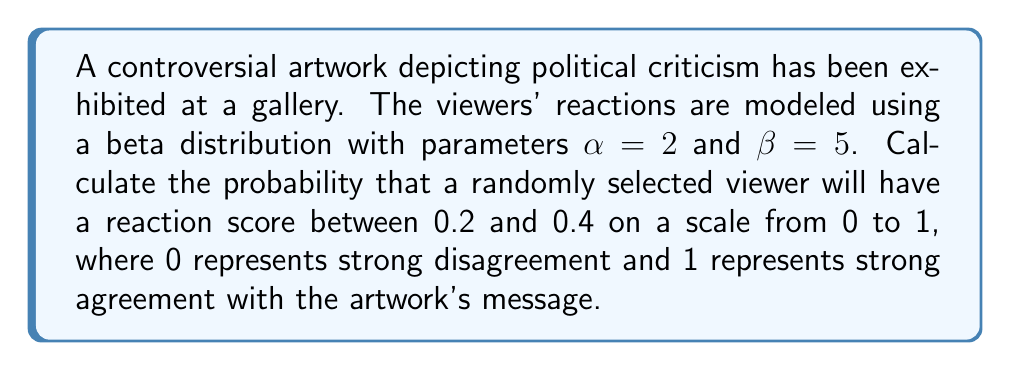Solve this math problem. To solve this problem, we need to use the cumulative distribution function (CDF) of the beta distribution. The steps are as follows:

1) The CDF of the beta distribution is given by the regularized incomplete beta function:

   $F(x; \alpha, \beta) = \frac{B(x; \alpha, \beta)}{B(\alpha, \beta)}$

   where $B(x; \alpha, \beta)$ is the incomplete beta function and $B(\alpha, \beta)$ is the beta function.

2) We need to calculate $P(0.2 < X < 0.4)$, which is equivalent to $F(0.4) - F(0.2)$.

3) Given $\alpha = 2$ and $\beta = 5$, we need to compute:

   $P(0.2 < X < 0.4) = F(0.4; 2, 5) - F(0.2; 2, 5)$

4) Using a statistical software or calculator with beta distribution functions:

   $F(0.4; 2, 5) \approx 0.5491$
   $F(0.2; 2, 5) \approx 0.2061$

5) Therefore:

   $P(0.2 < X < 0.4) = 0.5491 - 0.2061 = 0.3430$

This means there is approximately a 34.30% chance that a randomly selected viewer will have a reaction score between 0.2 and 0.4.
Answer: 0.3430 